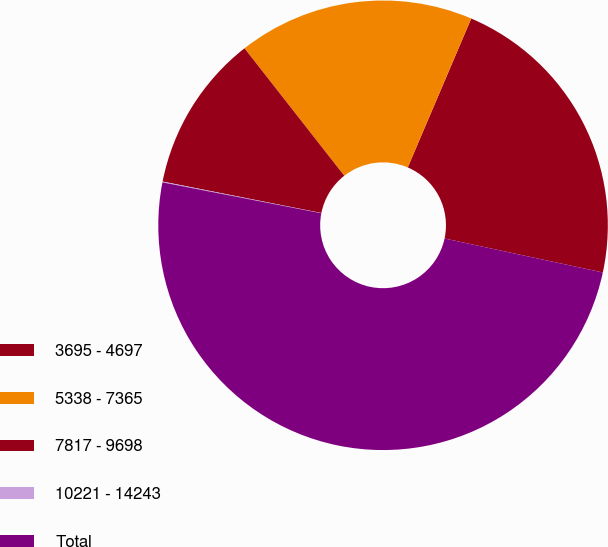Convert chart to OTSL. <chart><loc_0><loc_0><loc_500><loc_500><pie_chart><fcel>3695 - 4697<fcel>5338 - 7365<fcel>7817 - 9698<fcel>10221 - 14243<fcel>Total<nl><fcel>21.95%<fcel>16.99%<fcel>11.31%<fcel>0.06%<fcel>49.69%<nl></chart> 